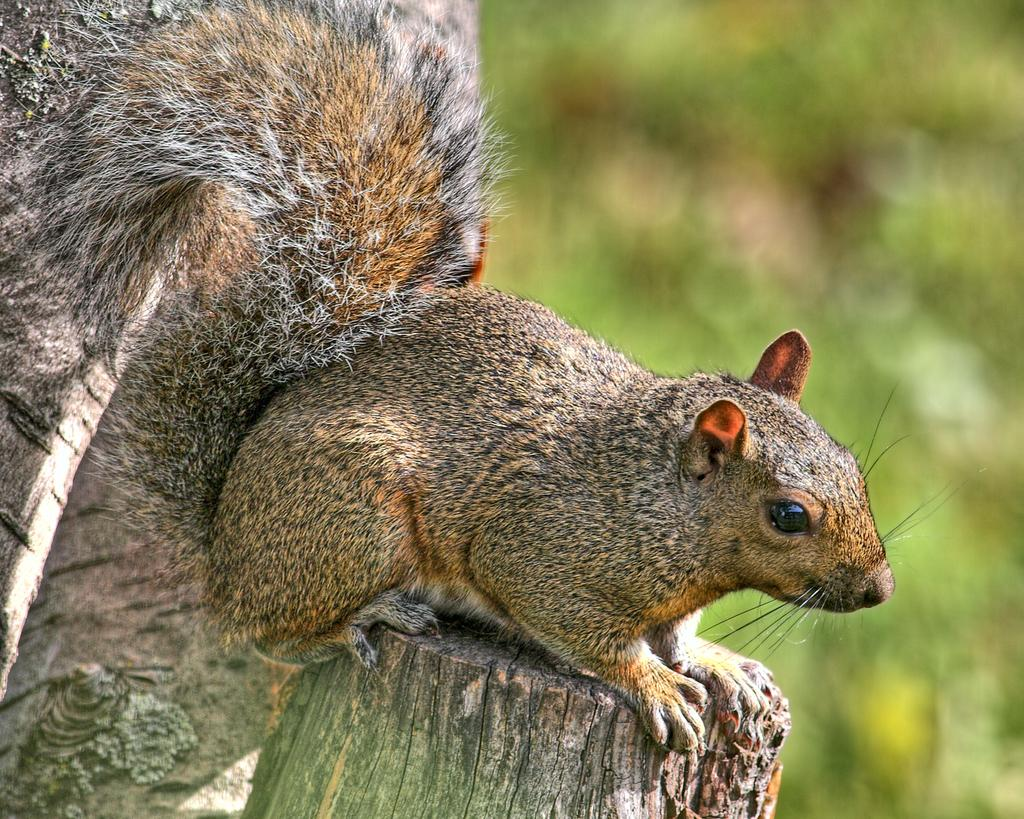What type of animal is in the image? There is a squirrel in the image. What surface is the squirrel on? The squirrel is on wood. What type of science experiment is the squirrel conducting in the image? There is no science experiment or any indication of one in the image; it simply features a squirrel on wood. 